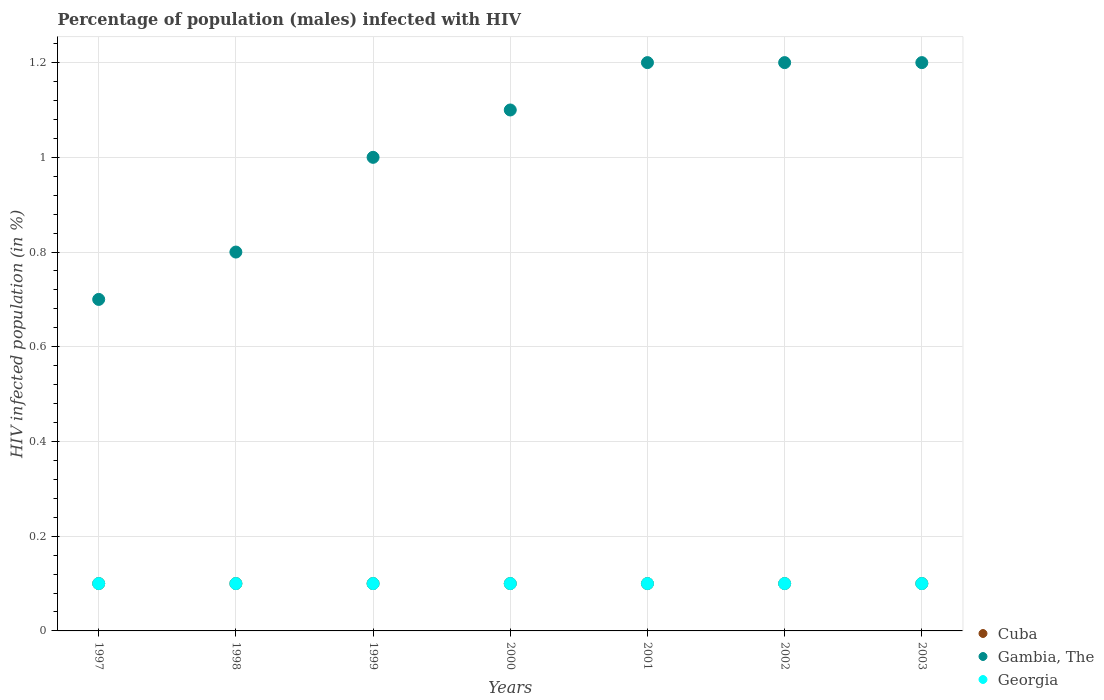Is the number of dotlines equal to the number of legend labels?
Your response must be concise. Yes. Across all years, what is the minimum percentage of HIV infected male population in Cuba?
Provide a short and direct response. 0.1. In which year was the percentage of HIV infected male population in Georgia maximum?
Make the answer very short. 1997. What is the total percentage of HIV infected male population in Georgia in the graph?
Your answer should be compact. 0.7. What is the average percentage of HIV infected male population in Georgia per year?
Provide a succinct answer. 0.1. What is the ratio of the percentage of HIV infected male population in Gambia, The in 2000 to that in 2002?
Provide a short and direct response. 0.92. Is the percentage of HIV infected male population in Cuba in 2002 less than that in 2003?
Make the answer very short. No. Is the difference between the percentage of HIV infected male population in Georgia in 2000 and 2002 greater than the difference between the percentage of HIV infected male population in Gambia, The in 2000 and 2002?
Your response must be concise. Yes. What is the difference between the highest and the lowest percentage of HIV infected male population in Gambia, The?
Your answer should be very brief. 0.5. How many years are there in the graph?
Offer a very short reply. 7. Does the graph contain grids?
Offer a very short reply. Yes. Where does the legend appear in the graph?
Offer a terse response. Bottom right. What is the title of the graph?
Provide a succinct answer. Percentage of population (males) infected with HIV. What is the label or title of the X-axis?
Offer a terse response. Years. What is the label or title of the Y-axis?
Your answer should be very brief. HIV infected population (in %). What is the HIV infected population (in %) in Gambia, The in 1997?
Provide a short and direct response. 0.7. What is the HIV infected population (in %) in Gambia, The in 1998?
Your answer should be compact. 0.8. What is the HIV infected population (in %) in Cuba in 1999?
Ensure brevity in your answer.  0.1. What is the HIV infected population (in %) of Gambia, The in 1999?
Offer a very short reply. 1. What is the HIV infected population (in %) in Georgia in 1999?
Give a very brief answer. 0.1. What is the HIV infected population (in %) of Gambia, The in 2000?
Offer a terse response. 1.1. What is the HIV infected population (in %) of Georgia in 2000?
Provide a succinct answer. 0.1. What is the HIV infected population (in %) of Georgia in 2001?
Provide a succinct answer. 0.1. What is the HIV infected population (in %) in Cuba in 2002?
Your response must be concise. 0.1. What is the HIV infected population (in %) in Gambia, The in 2002?
Make the answer very short. 1.2. What is the HIV infected population (in %) of Georgia in 2002?
Offer a very short reply. 0.1. What is the HIV infected population (in %) in Gambia, The in 2003?
Offer a very short reply. 1.2. What is the HIV infected population (in %) of Georgia in 2003?
Give a very brief answer. 0.1. Across all years, what is the maximum HIV infected population (in %) in Gambia, The?
Your answer should be compact. 1.2. Across all years, what is the minimum HIV infected population (in %) in Cuba?
Your answer should be compact. 0.1. Across all years, what is the minimum HIV infected population (in %) of Gambia, The?
Keep it short and to the point. 0.7. Across all years, what is the minimum HIV infected population (in %) in Georgia?
Offer a very short reply. 0.1. What is the total HIV infected population (in %) of Gambia, The in the graph?
Your answer should be compact. 7.2. What is the difference between the HIV infected population (in %) of Cuba in 1997 and that in 1998?
Your answer should be very brief. 0. What is the difference between the HIV infected population (in %) of Georgia in 1997 and that in 1998?
Offer a terse response. 0. What is the difference between the HIV infected population (in %) of Cuba in 1997 and that in 1999?
Your answer should be very brief. 0. What is the difference between the HIV infected population (in %) in Gambia, The in 1997 and that in 1999?
Your answer should be compact. -0.3. What is the difference between the HIV infected population (in %) of Georgia in 1997 and that in 2000?
Give a very brief answer. 0. What is the difference between the HIV infected population (in %) in Georgia in 1997 and that in 2002?
Ensure brevity in your answer.  0. What is the difference between the HIV infected population (in %) in Gambia, The in 1997 and that in 2003?
Provide a succinct answer. -0.5. What is the difference between the HIV infected population (in %) of Gambia, The in 1998 and that in 1999?
Your answer should be very brief. -0.2. What is the difference between the HIV infected population (in %) of Georgia in 1998 and that in 1999?
Offer a very short reply. 0. What is the difference between the HIV infected population (in %) of Cuba in 1998 and that in 2000?
Ensure brevity in your answer.  0. What is the difference between the HIV infected population (in %) of Georgia in 1998 and that in 2000?
Make the answer very short. 0. What is the difference between the HIV infected population (in %) of Gambia, The in 1998 and that in 2001?
Ensure brevity in your answer.  -0.4. What is the difference between the HIV infected population (in %) of Georgia in 1998 and that in 2001?
Offer a terse response. 0. What is the difference between the HIV infected population (in %) in Cuba in 1998 and that in 2002?
Offer a terse response. 0. What is the difference between the HIV infected population (in %) in Cuba in 1998 and that in 2003?
Offer a terse response. 0. What is the difference between the HIV infected population (in %) in Gambia, The in 1998 and that in 2003?
Provide a short and direct response. -0.4. What is the difference between the HIV infected population (in %) in Cuba in 1999 and that in 2000?
Ensure brevity in your answer.  0. What is the difference between the HIV infected population (in %) of Georgia in 1999 and that in 2000?
Your answer should be very brief. 0. What is the difference between the HIV infected population (in %) in Cuba in 1999 and that in 2001?
Your answer should be very brief. 0. What is the difference between the HIV infected population (in %) of Gambia, The in 1999 and that in 2001?
Ensure brevity in your answer.  -0.2. What is the difference between the HIV infected population (in %) of Gambia, The in 1999 and that in 2002?
Offer a terse response. -0.2. What is the difference between the HIV infected population (in %) in Georgia in 1999 and that in 2002?
Your answer should be compact. 0. What is the difference between the HIV infected population (in %) of Georgia in 2000 and that in 2001?
Provide a short and direct response. 0. What is the difference between the HIV infected population (in %) of Cuba in 2000 and that in 2002?
Your answer should be very brief. 0. What is the difference between the HIV infected population (in %) in Georgia in 2000 and that in 2002?
Provide a short and direct response. 0. What is the difference between the HIV infected population (in %) of Gambia, The in 2000 and that in 2003?
Offer a very short reply. -0.1. What is the difference between the HIV infected population (in %) in Georgia in 2001 and that in 2002?
Offer a very short reply. 0. What is the difference between the HIV infected population (in %) of Gambia, The in 2002 and that in 2003?
Provide a short and direct response. 0. What is the difference between the HIV infected population (in %) of Cuba in 1997 and the HIV infected population (in %) of Gambia, The in 1999?
Make the answer very short. -0.9. What is the difference between the HIV infected population (in %) in Cuba in 1997 and the HIV infected population (in %) in Gambia, The in 2000?
Your answer should be very brief. -1. What is the difference between the HIV infected population (in %) of Cuba in 1997 and the HIV infected population (in %) of Georgia in 2000?
Offer a terse response. 0. What is the difference between the HIV infected population (in %) of Gambia, The in 1997 and the HIV infected population (in %) of Georgia in 2000?
Offer a very short reply. 0.6. What is the difference between the HIV infected population (in %) of Cuba in 1997 and the HIV infected population (in %) of Georgia in 2001?
Provide a succinct answer. 0. What is the difference between the HIV infected population (in %) in Gambia, The in 1997 and the HIV infected population (in %) in Georgia in 2001?
Make the answer very short. 0.6. What is the difference between the HIV infected population (in %) of Cuba in 1997 and the HIV infected population (in %) of Gambia, The in 2002?
Make the answer very short. -1.1. What is the difference between the HIV infected population (in %) of Gambia, The in 1997 and the HIV infected population (in %) of Georgia in 2002?
Your answer should be compact. 0.6. What is the difference between the HIV infected population (in %) in Gambia, The in 1997 and the HIV infected population (in %) in Georgia in 2003?
Keep it short and to the point. 0.6. What is the difference between the HIV infected population (in %) of Cuba in 1998 and the HIV infected population (in %) of Gambia, The in 1999?
Your answer should be very brief. -0.9. What is the difference between the HIV infected population (in %) in Cuba in 1998 and the HIV infected population (in %) in Georgia in 1999?
Your answer should be very brief. 0. What is the difference between the HIV infected population (in %) of Gambia, The in 1998 and the HIV infected population (in %) of Georgia in 1999?
Offer a terse response. 0.7. What is the difference between the HIV infected population (in %) in Gambia, The in 1998 and the HIV infected population (in %) in Georgia in 2000?
Offer a very short reply. 0.7. What is the difference between the HIV infected population (in %) of Cuba in 1998 and the HIV infected population (in %) of Gambia, The in 2001?
Give a very brief answer. -1.1. What is the difference between the HIV infected population (in %) of Cuba in 1998 and the HIV infected population (in %) of Georgia in 2001?
Your answer should be very brief. 0. What is the difference between the HIV infected population (in %) in Gambia, The in 1998 and the HIV infected population (in %) in Georgia in 2001?
Your answer should be compact. 0.7. What is the difference between the HIV infected population (in %) in Gambia, The in 1998 and the HIV infected population (in %) in Georgia in 2002?
Offer a terse response. 0.7. What is the difference between the HIV infected population (in %) in Cuba in 1998 and the HIV infected population (in %) in Gambia, The in 2003?
Provide a short and direct response. -1.1. What is the difference between the HIV infected population (in %) in Cuba in 1998 and the HIV infected population (in %) in Georgia in 2003?
Give a very brief answer. 0. What is the difference between the HIV infected population (in %) in Cuba in 1999 and the HIV infected population (in %) in Gambia, The in 2000?
Keep it short and to the point. -1. What is the difference between the HIV infected population (in %) in Cuba in 1999 and the HIV infected population (in %) in Georgia in 2000?
Your answer should be very brief. 0. What is the difference between the HIV infected population (in %) of Cuba in 1999 and the HIV infected population (in %) of Gambia, The in 2001?
Your answer should be compact. -1.1. What is the difference between the HIV infected population (in %) in Gambia, The in 1999 and the HIV infected population (in %) in Georgia in 2001?
Offer a terse response. 0.9. What is the difference between the HIV infected population (in %) of Cuba in 1999 and the HIV infected population (in %) of Gambia, The in 2002?
Ensure brevity in your answer.  -1.1. What is the difference between the HIV infected population (in %) of Cuba in 1999 and the HIV infected population (in %) of Georgia in 2002?
Ensure brevity in your answer.  0. What is the difference between the HIV infected population (in %) of Gambia, The in 1999 and the HIV infected population (in %) of Georgia in 2002?
Provide a short and direct response. 0.9. What is the difference between the HIV infected population (in %) in Cuba in 1999 and the HIV infected population (in %) in Gambia, The in 2003?
Offer a terse response. -1.1. What is the difference between the HIV infected population (in %) of Cuba in 1999 and the HIV infected population (in %) of Georgia in 2003?
Provide a succinct answer. 0. What is the difference between the HIV infected population (in %) in Gambia, The in 2000 and the HIV infected population (in %) in Georgia in 2001?
Your answer should be very brief. 1. What is the difference between the HIV infected population (in %) in Cuba in 2000 and the HIV infected population (in %) in Gambia, The in 2002?
Your answer should be very brief. -1.1. What is the difference between the HIV infected population (in %) in Cuba in 2000 and the HIV infected population (in %) in Georgia in 2002?
Provide a short and direct response. 0. What is the difference between the HIV infected population (in %) in Gambia, The in 2000 and the HIV infected population (in %) in Georgia in 2003?
Give a very brief answer. 1. What is the difference between the HIV infected population (in %) in Cuba in 2001 and the HIV infected population (in %) in Gambia, The in 2002?
Your answer should be very brief. -1.1. What is the difference between the HIV infected population (in %) in Gambia, The in 2001 and the HIV infected population (in %) in Georgia in 2002?
Give a very brief answer. 1.1. What is the difference between the HIV infected population (in %) in Cuba in 2001 and the HIV infected population (in %) in Gambia, The in 2003?
Ensure brevity in your answer.  -1.1. What is the difference between the HIV infected population (in %) of Cuba in 2002 and the HIV infected population (in %) of Gambia, The in 2003?
Provide a succinct answer. -1.1. What is the difference between the HIV infected population (in %) of Gambia, The in 2002 and the HIV infected population (in %) of Georgia in 2003?
Make the answer very short. 1.1. What is the average HIV infected population (in %) of Gambia, The per year?
Give a very brief answer. 1.03. In the year 1998, what is the difference between the HIV infected population (in %) of Cuba and HIV infected population (in %) of Gambia, The?
Provide a short and direct response. -0.7. In the year 1998, what is the difference between the HIV infected population (in %) of Gambia, The and HIV infected population (in %) of Georgia?
Offer a very short reply. 0.7. In the year 1999, what is the difference between the HIV infected population (in %) in Cuba and HIV infected population (in %) in Gambia, The?
Your answer should be very brief. -0.9. In the year 1999, what is the difference between the HIV infected population (in %) of Gambia, The and HIV infected population (in %) of Georgia?
Offer a terse response. 0.9. In the year 2000, what is the difference between the HIV infected population (in %) in Cuba and HIV infected population (in %) in Gambia, The?
Your answer should be very brief. -1. In the year 2000, what is the difference between the HIV infected population (in %) in Cuba and HIV infected population (in %) in Georgia?
Provide a succinct answer. 0. In the year 2000, what is the difference between the HIV infected population (in %) in Gambia, The and HIV infected population (in %) in Georgia?
Make the answer very short. 1. In the year 2001, what is the difference between the HIV infected population (in %) in Cuba and HIV infected population (in %) in Georgia?
Keep it short and to the point. 0. In the year 2002, what is the difference between the HIV infected population (in %) of Cuba and HIV infected population (in %) of Gambia, The?
Provide a short and direct response. -1.1. In the year 2002, what is the difference between the HIV infected population (in %) of Cuba and HIV infected population (in %) of Georgia?
Offer a very short reply. 0. In the year 2003, what is the difference between the HIV infected population (in %) of Cuba and HIV infected population (in %) of Gambia, The?
Provide a short and direct response. -1.1. What is the ratio of the HIV infected population (in %) in Gambia, The in 1997 to that in 1998?
Keep it short and to the point. 0.88. What is the ratio of the HIV infected population (in %) of Georgia in 1997 to that in 1998?
Ensure brevity in your answer.  1. What is the ratio of the HIV infected population (in %) of Gambia, The in 1997 to that in 1999?
Give a very brief answer. 0.7. What is the ratio of the HIV infected population (in %) in Georgia in 1997 to that in 1999?
Your answer should be compact. 1. What is the ratio of the HIV infected population (in %) of Gambia, The in 1997 to that in 2000?
Give a very brief answer. 0.64. What is the ratio of the HIV infected population (in %) of Georgia in 1997 to that in 2000?
Keep it short and to the point. 1. What is the ratio of the HIV infected population (in %) in Gambia, The in 1997 to that in 2001?
Your response must be concise. 0.58. What is the ratio of the HIV infected population (in %) of Georgia in 1997 to that in 2001?
Offer a terse response. 1. What is the ratio of the HIV infected population (in %) of Cuba in 1997 to that in 2002?
Your response must be concise. 1. What is the ratio of the HIV infected population (in %) of Gambia, The in 1997 to that in 2002?
Your answer should be compact. 0.58. What is the ratio of the HIV infected population (in %) of Georgia in 1997 to that in 2002?
Ensure brevity in your answer.  1. What is the ratio of the HIV infected population (in %) of Cuba in 1997 to that in 2003?
Your answer should be very brief. 1. What is the ratio of the HIV infected population (in %) of Gambia, The in 1997 to that in 2003?
Give a very brief answer. 0.58. What is the ratio of the HIV infected population (in %) of Gambia, The in 1998 to that in 1999?
Offer a terse response. 0.8. What is the ratio of the HIV infected population (in %) of Gambia, The in 1998 to that in 2000?
Make the answer very short. 0.73. What is the ratio of the HIV infected population (in %) of Gambia, The in 1998 to that in 2001?
Provide a short and direct response. 0.67. What is the ratio of the HIV infected population (in %) in Cuba in 1998 to that in 2002?
Give a very brief answer. 1. What is the ratio of the HIV infected population (in %) of Gambia, The in 1998 to that in 2002?
Offer a very short reply. 0.67. What is the ratio of the HIV infected population (in %) of Gambia, The in 1998 to that in 2003?
Make the answer very short. 0.67. What is the ratio of the HIV infected population (in %) of Cuba in 1999 to that in 2000?
Your response must be concise. 1. What is the ratio of the HIV infected population (in %) in Cuba in 1999 to that in 2002?
Your answer should be very brief. 1. What is the ratio of the HIV infected population (in %) in Georgia in 1999 to that in 2002?
Offer a very short reply. 1. What is the ratio of the HIV infected population (in %) in Gambia, The in 1999 to that in 2003?
Provide a succinct answer. 0.83. What is the ratio of the HIV infected population (in %) of Georgia in 1999 to that in 2003?
Your answer should be compact. 1. What is the ratio of the HIV infected population (in %) of Cuba in 2000 to that in 2002?
Ensure brevity in your answer.  1. What is the ratio of the HIV infected population (in %) of Cuba in 2000 to that in 2003?
Your response must be concise. 1. What is the ratio of the HIV infected population (in %) of Cuba in 2001 to that in 2002?
Ensure brevity in your answer.  1. What is the ratio of the HIV infected population (in %) in Gambia, The in 2001 to that in 2002?
Offer a terse response. 1. What is the ratio of the HIV infected population (in %) in Georgia in 2001 to that in 2002?
Keep it short and to the point. 1. What is the ratio of the HIV infected population (in %) of Georgia in 2001 to that in 2003?
Provide a succinct answer. 1. What is the difference between the highest and the second highest HIV infected population (in %) of Cuba?
Your answer should be compact. 0. What is the difference between the highest and the lowest HIV infected population (in %) in Gambia, The?
Offer a very short reply. 0.5. 